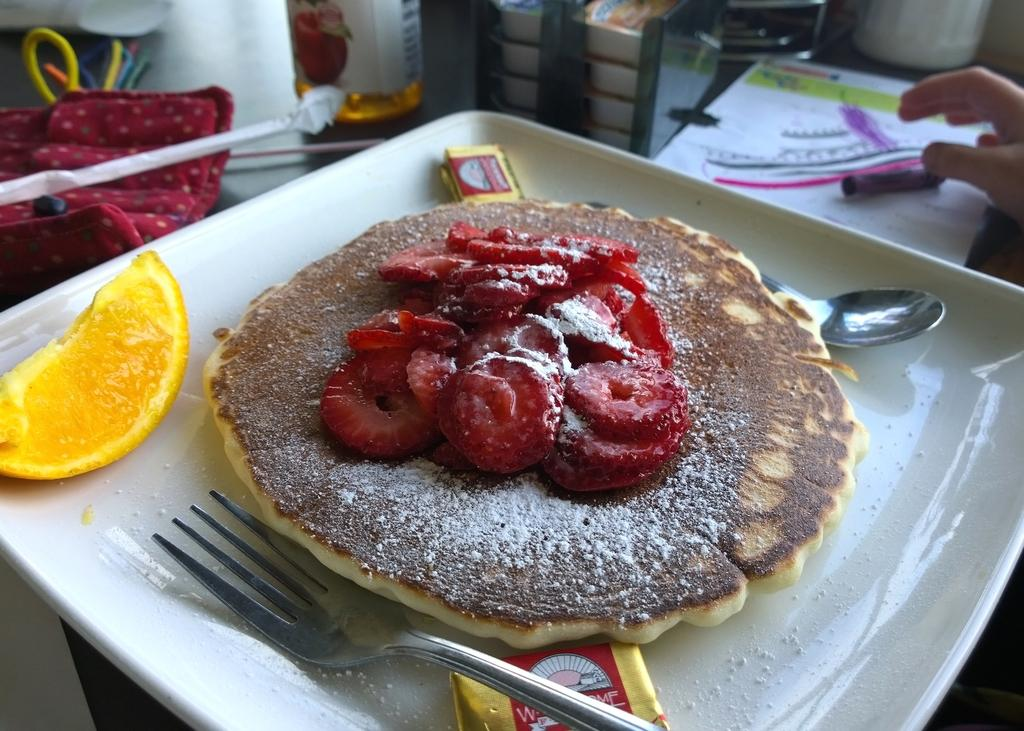What is located at the bottom of the image? There is a table at the bottom of the image. What items can be seen on the table? There are plates, spoons, food, fruits, a cloth, a bottle, and a paper on the table. What type of utensils are on the table? There are spoons on the table. What type of food is visible on the table? There is food on the table, but the specific type is not mentioned in the facts. What type of fruits are on the table? There are fruits on the table, but the specific type is not mentioned in the facts. What type of cloth is on the table? There is a cloth on the table, but the specific type is not mentioned in the facts. What type of bottle is on the table? There is a bottle on the table, but the specific type is not mentioned in the facts. What type of paper is on the table? There is a paper on the table, but the specific type is not mentioned in the facts. Is there any indication of a person in the image? Yes, there is a hand visible in the image. What type of volcano can be seen erupting in the image? There is no volcano present in the image. What type of jeans is the person wearing in the image? There is no person wearing jeans in the image, as only a hand is visible. What type of art is displayed on the table in the image? There is no art displayed on the table in the image. 